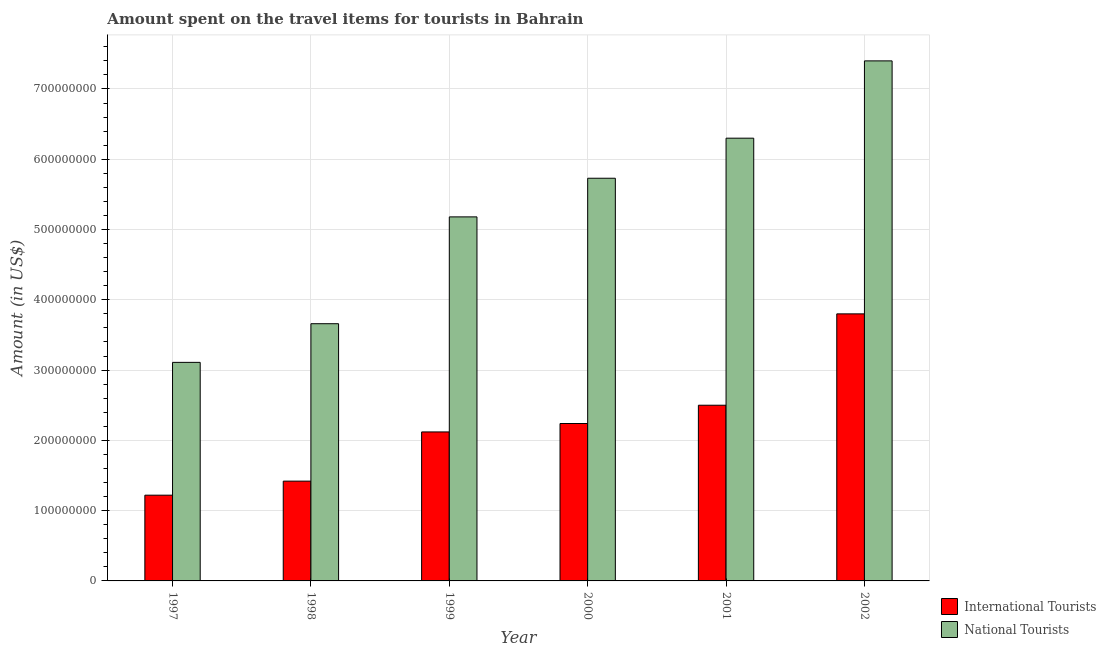How many different coloured bars are there?
Offer a very short reply. 2. Are the number of bars on each tick of the X-axis equal?
Your response must be concise. Yes. How many bars are there on the 5th tick from the left?
Give a very brief answer. 2. How many bars are there on the 5th tick from the right?
Give a very brief answer. 2. What is the label of the 2nd group of bars from the left?
Your answer should be very brief. 1998. In how many cases, is the number of bars for a given year not equal to the number of legend labels?
Make the answer very short. 0. What is the amount spent on travel items of international tourists in 2000?
Offer a terse response. 2.24e+08. Across all years, what is the maximum amount spent on travel items of international tourists?
Provide a succinct answer. 3.80e+08. Across all years, what is the minimum amount spent on travel items of national tourists?
Offer a very short reply. 3.11e+08. In which year was the amount spent on travel items of international tourists maximum?
Your answer should be very brief. 2002. In which year was the amount spent on travel items of international tourists minimum?
Offer a very short reply. 1997. What is the total amount spent on travel items of national tourists in the graph?
Provide a short and direct response. 3.14e+09. What is the difference between the amount spent on travel items of international tourists in 1998 and that in 2000?
Your response must be concise. -8.20e+07. What is the difference between the amount spent on travel items of international tourists in 2001 and the amount spent on travel items of national tourists in 2002?
Offer a very short reply. -1.30e+08. What is the average amount spent on travel items of international tourists per year?
Give a very brief answer. 2.22e+08. In the year 2000, what is the difference between the amount spent on travel items of national tourists and amount spent on travel items of international tourists?
Ensure brevity in your answer.  0. What is the ratio of the amount spent on travel items of national tourists in 1999 to that in 2001?
Make the answer very short. 0.82. Is the difference between the amount spent on travel items of international tourists in 1998 and 2001 greater than the difference between the amount spent on travel items of national tourists in 1998 and 2001?
Your answer should be compact. No. What is the difference between the highest and the second highest amount spent on travel items of national tourists?
Make the answer very short. 1.10e+08. What is the difference between the highest and the lowest amount spent on travel items of international tourists?
Your answer should be compact. 2.58e+08. Is the sum of the amount spent on travel items of national tourists in 1999 and 2001 greater than the maximum amount spent on travel items of international tourists across all years?
Provide a short and direct response. Yes. What does the 2nd bar from the left in 2001 represents?
Give a very brief answer. National Tourists. What does the 2nd bar from the right in 2001 represents?
Offer a terse response. International Tourists. How many bars are there?
Ensure brevity in your answer.  12. Are all the bars in the graph horizontal?
Your answer should be compact. No. How many years are there in the graph?
Your answer should be very brief. 6. Does the graph contain grids?
Provide a short and direct response. Yes. Where does the legend appear in the graph?
Provide a short and direct response. Bottom right. How are the legend labels stacked?
Your response must be concise. Vertical. What is the title of the graph?
Offer a very short reply. Amount spent on the travel items for tourists in Bahrain. What is the label or title of the X-axis?
Keep it short and to the point. Year. What is the label or title of the Y-axis?
Make the answer very short. Amount (in US$). What is the Amount (in US$) of International Tourists in 1997?
Provide a succinct answer. 1.22e+08. What is the Amount (in US$) of National Tourists in 1997?
Offer a terse response. 3.11e+08. What is the Amount (in US$) in International Tourists in 1998?
Your answer should be compact. 1.42e+08. What is the Amount (in US$) in National Tourists in 1998?
Your response must be concise. 3.66e+08. What is the Amount (in US$) in International Tourists in 1999?
Your answer should be compact. 2.12e+08. What is the Amount (in US$) in National Tourists in 1999?
Your answer should be compact. 5.18e+08. What is the Amount (in US$) of International Tourists in 2000?
Your answer should be compact. 2.24e+08. What is the Amount (in US$) in National Tourists in 2000?
Your response must be concise. 5.73e+08. What is the Amount (in US$) in International Tourists in 2001?
Give a very brief answer. 2.50e+08. What is the Amount (in US$) in National Tourists in 2001?
Your response must be concise. 6.30e+08. What is the Amount (in US$) in International Tourists in 2002?
Ensure brevity in your answer.  3.80e+08. What is the Amount (in US$) in National Tourists in 2002?
Offer a very short reply. 7.40e+08. Across all years, what is the maximum Amount (in US$) in International Tourists?
Keep it short and to the point. 3.80e+08. Across all years, what is the maximum Amount (in US$) of National Tourists?
Give a very brief answer. 7.40e+08. Across all years, what is the minimum Amount (in US$) of International Tourists?
Keep it short and to the point. 1.22e+08. Across all years, what is the minimum Amount (in US$) in National Tourists?
Provide a short and direct response. 3.11e+08. What is the total Amount (in US$) of International Tourists in the graph?
Your response must be concise. 1.33e+09. What is the total Amount (in US$) of National Tourists in the graph?
Your answer should be very brief. 3.14e+09. What is the difference between the Amount (in US$) of International Tourists in 1997 and that in 1998?
Give a very brief answer. -2.00e+07. What is the difference between the Amount (in US$) in National Tourists in 1997 and that in 1998?
Your response must be concise. -5.50e+07. What is the difference between the Amount (in US$) in International Tourists in 1997 and that in 1999?
Your answer should be very brief. -9.00e+07. What is the difference between the Amount (in US$) in National Tourists in 1997 and that in 1999?
Offer a very short reply. -2.07e+08. What is the difference between the Amount (in US$) of International Tourists in 1997 and that in 2000?
Your response must be concise. -1.02e+08. What is the difference between the Amount (in US$) in National Tourists in 1997 and that in 2000?
Keep it short and to the point. -2.62e+08. What is the difference between the Amount (in US$) of International Tourists in 1997 and that in 2001?
Your answer should be very brief. -1.28e+08. What is the difference between the Amount (in US$) in National Tourists in 1997 and that in 2001?
Give a very brief answer. -3.19e+08. What is the difference between the Amount (in US$) of International Tourists in 1997 and that in 2002?
Your answer should be very brief. -2.58e+08. What is the difference between the Amount (in US$) in National Tourists in 1997 and that in 2002?
Provide a succinct answer. -4.29e+08. What is the difference between the Amount (in US$) in International Tourists in 1998 and that in 1999?
Make the answer very short. -7.00e+07. What is the difference between the Amount (in US$) of National Tourists in 1998 and that in 1999?
Your answer should be compact. -1.52e+08. What is the difference between the Amount (in US$) of International Tourists in 1998 and that in 2000?
Your response must be concise. -8.20e+07. What is the difference between the Amount (in US$) in National Tourists in 1998 and that in 2000?
Offer a very short reply. -2.07e+08. What is the difference between the Amount (in US$) of International Tourists in 1998 and that in 2001?
Make the answer very short. -1.08e+08. What is the difference between the Amount (in US$) of National Tourists in 1998 and that in 2001?
Keep it short and to the point. -2.64e+08. What is the difference between the Amount (in US$) of International Tourists in 1998 and that in 2002?
Offer a terse response. -2.38e+08. What is the difference between the Amount (in US$) in National Tourists in 1998 and that in 2002?
Your answer should be very brief. -3.74e+08. What is the difference between the Amount (in US$) in International Tourists in 1999 and that in 2000?
Ensure brevity in your answer.  -1.20e+07. What is the difference between the Amount (in US$) of National Tourists in 1999 and that in 2000?
Make the answer very short. -5.50e+07. What is the difference between the Amount (in US$) of International Tourists in 1999 and that in 2001?
Keep it short and to the point. -3.80e+07. What is the difference between the Amount (in US$) in National Tourists in 1999 and that in 2001?
Keep it short and to the point. -1.12e+08. What is the difference between the Amount (in US$) of International Tourists in 1999 and that in 2002?
Give a very brief answer. -1.68e+08. What is the difference between the Amount (in US$) in National Tourists in 1999 and that in 2002?
Your answer should be compact. -2.22e+08. What is the difference between the Amount (in US$) of International Tourists in 2000 and that in 2001?
Give a very brief answer. -2.60e+07. What is the difference between the Amount (in US$) in National Tourists in 2000 and that in 2001?
Your answer should be compact. -5.70e+07. What is the difference between the Amount (in US$) of International Tourists in 2000 and that in 2002?
Offer a very short reply. -1.56e+08. What is the difference between the Amount (in US$) of National Tourists in 2000 and that in 2002?
Provide a succinct answer. -1.67e+08. What is the difference between the Amount (in US$) in International Tourists in 2001 and that in 2002?
Provide a succinct answer. -1.30e+08. What is the difference between the Amount (in US$) in National Tourists in 2001 and that in 2002?
Your answer should be compact. -1.10e+08. What is the difference between the Amount (in US$) of International Tourists in 1997 and the Amount (in US$) of National Tourists in 1998?
Give a very brief answer. -2.44e+08. What is the difference between the Amount (in US$) in International Tourists in 1997 and the Amount (in US$) in National Tourists in 1999?
Your answer should be compact. -3.96e+08. What is the difference between the Amount (in US$) of International Tourists in 1997 and the Amount (in US$) of National Tourists in 2000?
Your answer should be compact. -4.51e+08. What is the difference between the Amount (in US$) of International Tourists in 1997 and the Amount (in US$) of National Tourists in 2001?
Make the answer very short. -5.08e+08. What is the difference between the Amount (in US$) in International Tourists in 1997 and the Amount (in US$) in National Tourists in 2002?
Your answer should be compact. -6.18e+08. What is the difference between the Amount (in US$) in International Tourists in 1998 and the Amount (in US$) in National Tourists in 1999?
Your answer should be compact. -3.76e+08. What is the difference between the Amount (in US$) in International Tourists in 1998 and the Amount (in US$) in National Tourists in 2000?
Keep it short and to the point. -4.31e+08. What is the difference between the Amount (in US$) in International Tourists in 1998 and the Amount (in US$) in National Tourists in 2001?
Make the answer very short. -4.88e+08. What is the difference between the Amount (in US$) of International Tourists in 1998 and the Amount (in US$) of National Tourists in 2002?
Offer a terse response. -5.98e+08. What is the difference between the Amount (in US$) of International Tourists in 1999 and the Amount (in US$) of National Tourists in 2000?
Provide a short and direct response. -3.61e+08. What is the difference between the Amount (in US$) in International Tourists in 1999 and the Amount (in US$) in National Tourists in 2001?
Give a very brief answer. -4.18e+08. What is the difference between the Amount (in US$) of International Tourists in 1999 and the Amount (in US$) of National Tourists in 2002?
Offer a very short reply. -5.28e+08. What is the difference between the Amount (in US$) of International Tourists in 2000 and the Amount (in US$) of National Tourists in 2001?
Make the answer very short. -4.06e+08. What is the difference between the Amount (in US$) of International Tourists in 2000 and the Amount (in US$) of National Tourists in 2002?
Ensure brevity in your answer.  -5.16e+08. What is the difference between the Amount (in US$) in International Tourists in 2001 and the Amount (in US$) in National Tourists in 2002?
Your answer should be compact. -4.90e+08. What is the average Amount (in US$) of International Tourists per year?
Give a very brief answer. 2.22e+08. What is the average Amount (in US$) of National Tourists per year?
Provide a succinct answer. 5.23e+08. In the year 1997, what is the difference between the Amount (in US$) of International Tourists and Amount (in US$) of National Tourists?
Offer a very short reply. -1.89e+08. In the year 1998, what is the difference between the Amount (in US$) in International Tourists and Amount (in US$) in National Tourists?
Provide a succinct answer. -2.24e+08. In the year 1999, what is the difference between the Amount (in US$) of International Tourists and Amount (in US$) of National Tourists?
Provide a succinct answer. -3.06e+08. In the year 2000, what is the difference between the Amount (in US$) in International Tourists and Amount (in US$) in National Tourists?
Give a very brief answer. -3.49e+08. In the year 2001, what is the difference between the Amount (in US$) of International Tourists and Amount (in US$) of National Tourists?
Offer a very short reply. -3.80e+08. In the year 2002, what is the difference between the Amount (in US$) of International Tourists and Amount (in US$) of National Tourists?
Ensure brevity in your answer.  -3.60e+08. What is the ratio of the Amount (in US$) of International Tourists in 1997 to that in 1998?
Provide a succinct answer. 0.86. What is the ratio of the Amount (in US$) in National Tourists in 1997 to that in 1998?
Make the answer very short. 0.85. What is the ratio of the Amount (in US$) in International Tourists in 1997 to that in 1999?
Offer a terse response. 0.58. What is the ratio of the Amount (in US$) of National Tourists in 1997 to that in 1999?
Provide a short and direct response. 0.6. What is the ratio of the Amount (in US$) of International Tourists in 1997 to that in 2000?
Provide a short and direct response. 0.54. What is the ratio of the Amount (in US$) in National Tourists in 1997 to that in 2000?
Provide a succinct answer. 0.54. What is the ratio of the Amount (in US$) of International Tourists in 1997 to that in 2001?
Give a very brief answer. 0.49. What is the ratio of the Amount (in US$) of National Tourists in 1997 to that in 2001?
Provide a short and direct response. 0.49. What is the ratio of the Amount (in US$) of International Tourists in 1997 to that in 2002?
Provide a succinct answer. 0.32. What is the ratio of the Amount (in US$) of National Tourists in 1997 to that in 2002?
Ensure brevity in your answer.  0.42. What is the ratio of the Amount (in US$) in International Tourists in 1998 to that in 1999?
Keep it short and to the point. 0.67. What is the ratio of the Amount (in US$) in National Tourists in 1998 to that in 1999?
Your response must be concise. 0.71. What is the ratio of the Amount (in US$) of International Tourists in 1998 to that in 2000?
Offer a terse response. 0.63. What is the ratio of the Amount (in US$) of National Tourists in 1998 to that in 2000?
Your answer should be compact. 0.64. What is the ratio of the Amount (in US$) of International Tourists in 1998 to that in 2001?
Provide a succinct answer. 0.57. What is the ratio of the Amount (in US$) of National Tourists in 1998 to that in 2001?
Make the answer very short. 0.58. What is the ratio of the Amount (in US$) in International Tourists in 1998 to that in 2002?
Your response must be concise. 0.37. What is the ratio of the Amount (in US$) of National Tourists in 1998 to that in 2002?
Ensure brevity in your answer.  0.49. What is the ratio of the Amount (in US$) of International Tourists in 1999 to that in 2000?
Your answer should be very brief. 0.95. What is the ratio of the Amount (in US$) of National Tourists in 1999 to that in 2000?
Offer a very short reply. 0.9. What is the ratio of the Amount (in US$) in International Tourists in 1999 to that in 2001?
Give a very brief answer. 0.85. What is the ratio of the Amount (in US$) in National Tourists in 1999 to that in 2001?
Your answer should be very brief. 0.82. What is the ratio of the Amount (in US$) of International Tourists in 1999 to that in 2002?
Offer a very short reply. 0.56. What is the ratio of the Amount (in US$) in International Tourists in 2000 to that in 2001?
Your answer should be very brief. 0.9. What is the ratio of the Amount (in US$) in National Tourists in 2000 to that in 2001?
Your answer should be compact. 0.91. What is the ratio of the Amount (in US$) of International Tourists in 2000 to that in 2002?
Your answer should be compact. 0.59. What is the ratio of the Amount (in US$) of National Tourists in 2000 to that in 2002?
Make the answer very short. 0.77. What is the ratio of the Amount (in US$) in International Tourists in 2001 to that in 2002?
Provide a succinct answer. 0.66. What is the ratio of the Amount (in US$) of National Tourists in 2001 to that in 2002?
Keep it short and to the point. 0.85. What is the difference between the highest and the second highest Amount (in US$) of International Tourists?
Provide a succinct answer. 1.30e+08. What is the difference between the highest and the second highest Amount (in US$) in National Tourists?
Offer a very short reply. 1.10e+08. What is the difference between the highest and the lowest Amount (in US$) of International Tourists?
Offer a terse response. 2.58e+08. What is the difference between the highest and the lowest Amount (in US$) in National Tourists?
Ensure brevity in your answer.  4.29e+08. 